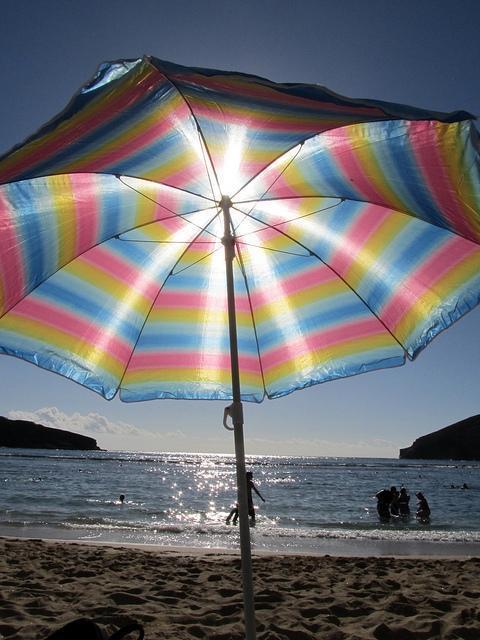How many umbrellas can you see in this photo?
Give a very brief answer. 1. How many support wires can we count in the umbrella?
Give a very brief answer. 8. 